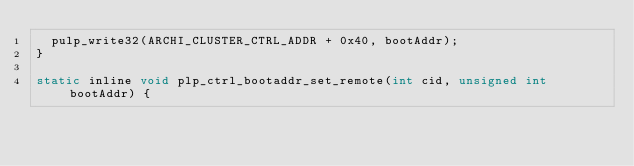<code> <loc_0><loc_0><loc_500><loc_500><_C_>  pulp_write32(ARCHI_CLUSTER_CTRL_ADDR + 0x40, bootAddr);
}

static inline void plp_ctrl_bootaddr_set_remote(int cid, unsigned int bootAddr) {</code> 